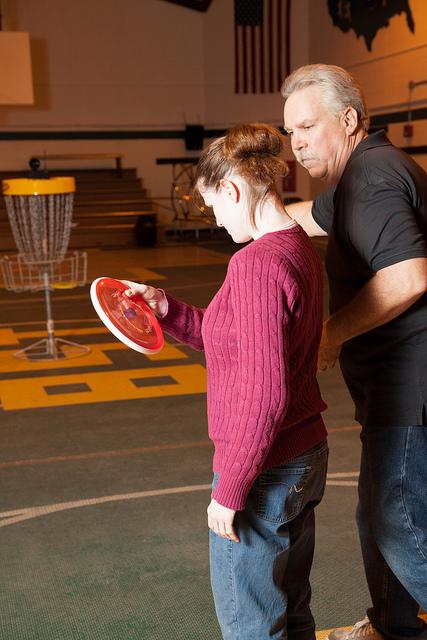How many balls are in the photo?
Be succinct. 0. Is there a map of the United States on the wall?
Write a very short answer. Yes. What is this person holding?
Concise answer only. Frisbee. Where are they?
Write a very short answer. Gym. What game is this little boy playing?
Answer briefly. Frisbee. What color are the numbers on the floor?
Give a very brief answer. Yellow. What does she have in her hand?
Be succinct. Frisbee. Is she wearing a hat?
Give a very brief answer. No. Did this girl win?
Concise answer only. No. 